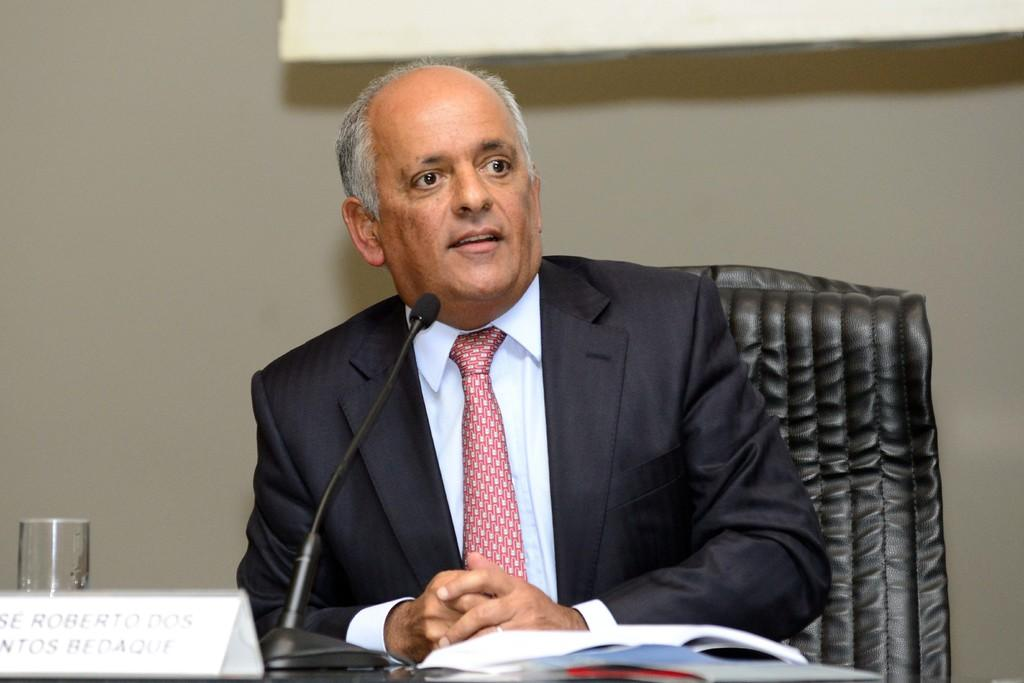What is the man in the image doing? The man is sitting on a chair in the image. Where is the man located in relation to the table? The man is at a table in the image. What can be seen on the table? There is a glass, a microphone (mike), and papers on the table in the image. What is visible in the background of the image? There is a wall in the background of the image. What is on the wall in the image? There is an object on the wall in the image. What type of sack is the queen holding in the image? There is no queen or sack present in the image. What level of difficulty is the man facing in the image? The image does not indicate any level of difficulty or challenge that the man is facing. 